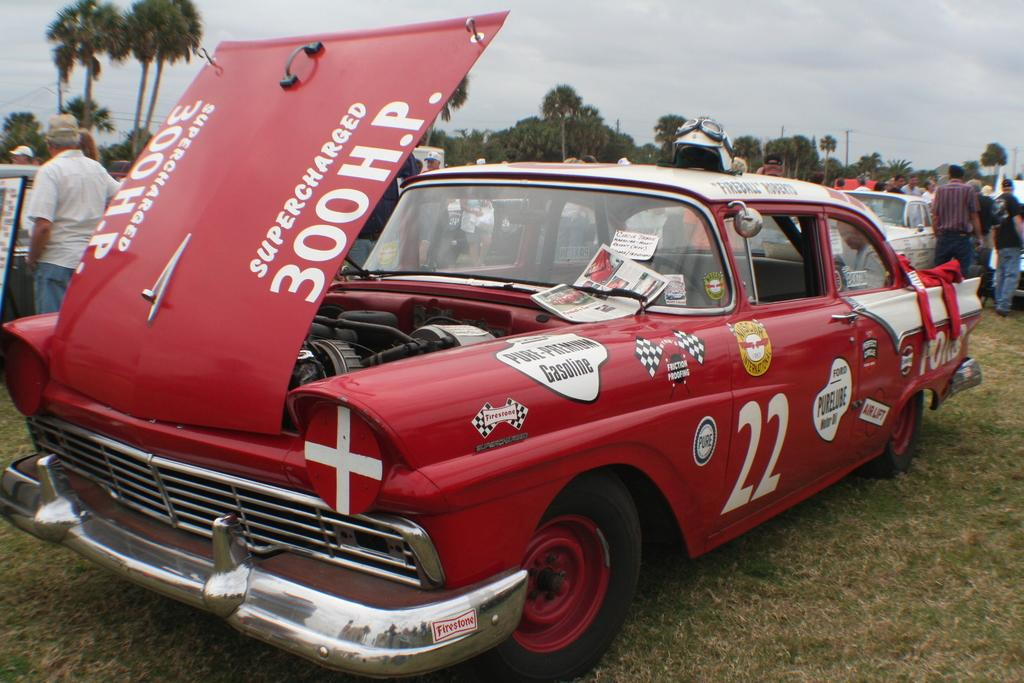What type of objects are colorful in the image? There are colorful vehicles in the image. What natural elements can be seen in the image? There are trees visible in the image. Who or what else is present in the image? There are people present in the image. What is the color of the sky in the image? The sky is blue and white in color. What type of brick is being used to build the floor in the image? There is no mention of a floor or brick in the image; it features colorful vehicles, trees, people, and a blue and white sky. 